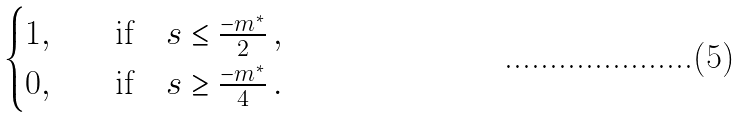Convert formula to latex. <formula><loc_0><loc_0><loc_500><loc_500>\begin{cases} 1 , \quad & \text {if} \quad s \leq \frac { - m ^ { * } } { 2 } \, , \\ 0 , \quad & \text {if} \quad s \geq \frac { - m ^ { * } } { 4 } \, . \end{cases}</formula> 